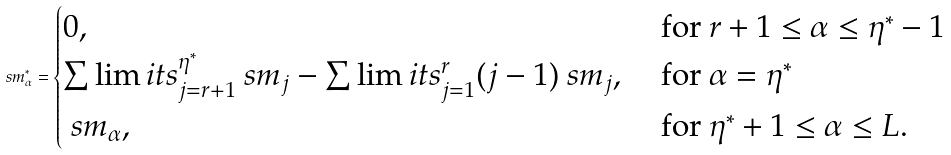Convert formula to latex. <formula><loc_0><loc_0><loc_500><loc_500>\ s m _ { \alpha } ^ { * } = \begin{cases} 0 , & \text { for } r + 1 \leq \alpha \leq \eta ^ { * } - 1 \\ \sum \lim i t s _ { j = r + 1 } ^ { \eta ^ { * } } \ s m _ { j } - \sum \lim i t s _ { j = 1 } ^ { r } ( j - 1 ) \ s m _ { j } , & \text { for } \alpha = \eta ^ { * } \\ \ s m _ { \alpha } , & \text { for } \eta ^ { * } + 1 \leq \alpha \leq L . \end{cases}</formula> 